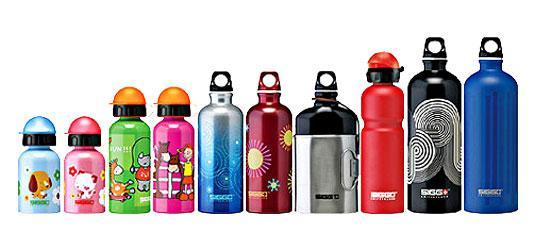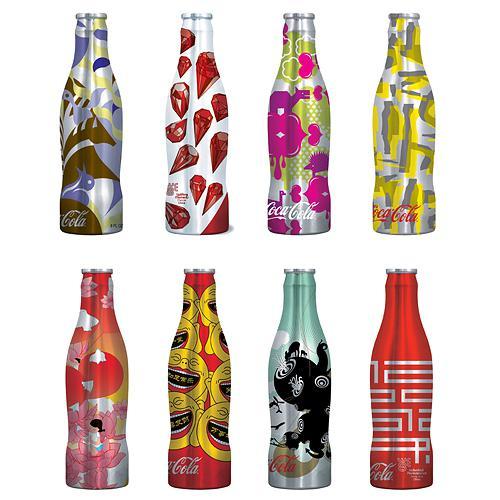The first image is the image on the left, the second image is the image on the right. Assess this claim about the two images: "There are more bottles in the left image than the right.". Correct or not? Answer yes or no. Yes. 